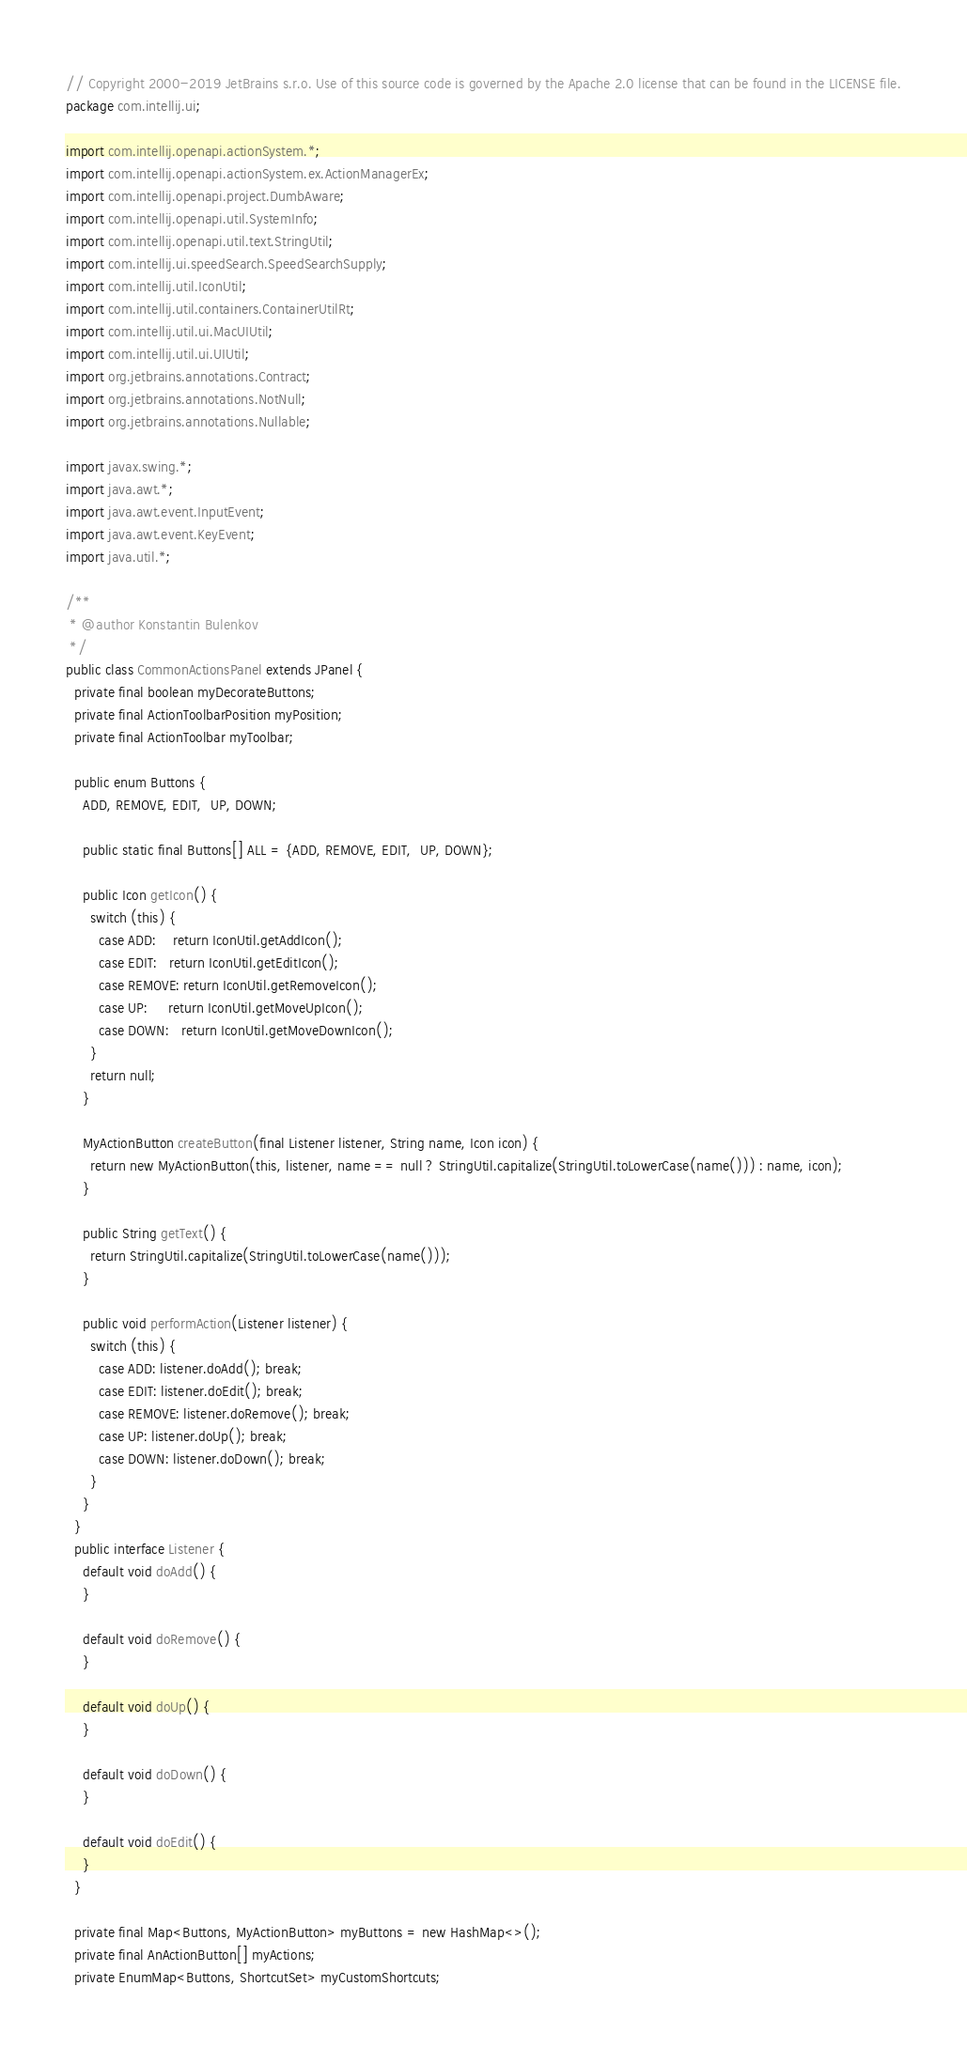<code> <loc_0><loc_0><loc_500><loc_500><_Java_>// Copyright 2000-2019 JetBrains s.r.o. Use of this source code is governed by the Apache 2.0 license that can be found in the LICENSE file.
package com.intellij.ui;

import com.intellij.openapi.actionSystem.*;
import com.intellij.openapi.actionSystem.ex.ActionManagerEx;
import com.intellij.openapi.project.DumbAware;
import com.intellij.openapi.util.SystemInfo;
import com.intellij.openapi.util.text.StringUtil;
import com.intellij.ui.speedSearch.SpeedSearchSupply;
import com.intellij.util.IconUtil;
import com.intellij.util.containers.ContainerUtilRt;
import com.intellij.util.ui.MacUIUtil;
import com.intellij.util.ui.UIUtil;
import org.jetbrains.annotations.Contract;
import org.jetbrains.annotations.NotNull;
import org.jetbrains.annotations.Nullable;

import javax.swing.*;
import java.awt.*;
import java.awt.event.InputEvent;
import java.awt.event.KeyEvent;
import java.util.*;

/**
 * @author Konstantin Bulenkov
 */
public class CommonActionsPanel extends JPanel {
  private final boolean myDecorateButtons;
  private final ActionToolbarPosition myPosition;
  private final ActionToolbar myToolbar;

  public enum Buttons {
    ADD, REMOVE, EDIT,  UP, DOWN;

    public static final Buttons[] ALL = {ADD, REMOVE, EDIT,  UP, DOWN};

    public Icon getIcon() {
      switch (this) {
        case ADD:    return IconUtil.getAddIcon();
        case EDIT:   return IconUtil.getEditIcon();
        case REMOVE: return IconUtil.getRemoveIcon();
        case UP:     return IconUtil.getMoveUpIcon();
        case DOWN:   return IconUtil.getMoveDownIcon();
      }
      return null;
    }

    MyActionButton createButton(final Listener listener, String name, Icon icon) {
      return new MyActionButton(this, listener, name == null ? StringUtil.capitalize(StringUtil.toLowerCase(name())) : name, icon);
    }

    public String getText() {
      return StringUtil.capitalize(StringUtil.toLowerCase(name()));
    }

    public void performAction(Listener listener) {
      switch (this) {
        case ADD: listener.doAdd(); break;
        case EDIT: listener.doEdit(); break;
        case REMOVE: listener.doRemove(); break;
        case UP: listener.doUp(); break;
        case DOWN: listener.doDown(); break;
      }
    }
  }
  public interface Listener {
    default void doAdd() {
    }

    default void doRemove() {
    }

    default void doUp() {
    }

    default void doDown() {
    }

    default void doEdit() {
    }
  }

  private final Map<Buttons, MyActionButton> myButtons = new HashMap<>();
  private final AnActionButton[] myActions;
  private EnumMap<Buttons, ShortcutSet> myCustomShortcuts;
</code> 